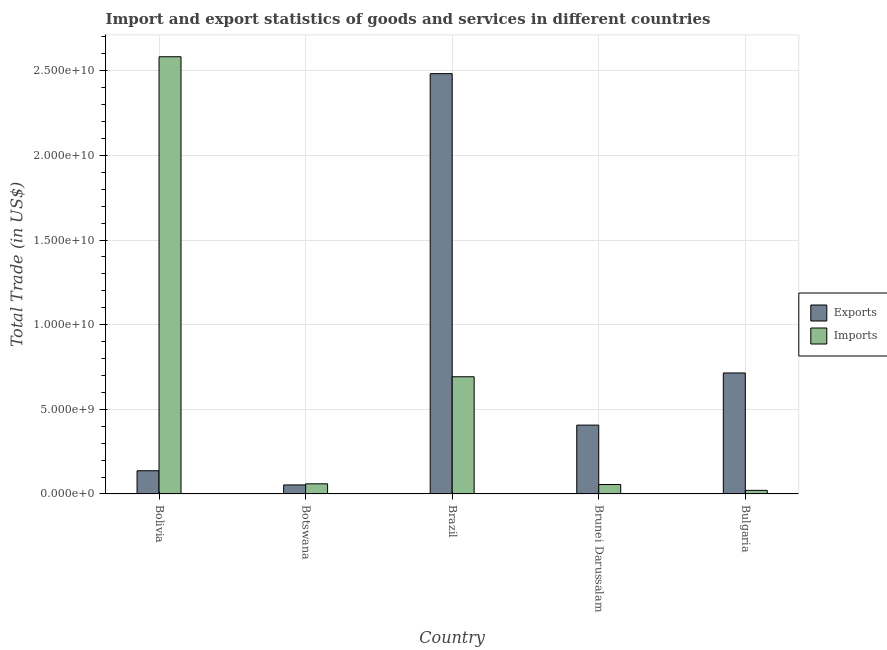Are the number of bars per tick equal to the number of legend labels?
Keep it short and to the point. Yes. Are the number of bars on each tick of the X-axis equal?
Offer a terse response. Yes. How many bars are there on the 2nd tick from the right?
Offer a terse response. 2. In how many cases, is the number of bars for a given country not equal to the number of legend labels?
Provide a short and direct response. 0. What is the export of goods and services in Bolivia?
Give a very brief answer. 1.37e+09. Across all countries, what is the maximum export of goods and services?
Your response must be concise. 2.48e+1. Across all countries, what is the minimum export of goods and services?
Give a very brief answer. 5.34e+08. In which country was the export of goods and services minimum?
Your answer should be very brief. Botswana. What is the total export of goods and services in the graph?
Your answer should be compact. 3.79e+1. What is the difference between the imports of goods and services in Bolivia and that in Brunei Darussalam?
Give a very brief answer. 2.53e+1. What is the difference between the imports of goods and services in Bolivia and the export of goods and services in Brazil?
Your answer should be very brief. 9.99e+08. What is the average imports of goods and services per country?
Provide a succinct answer. 6.82e+09. What is the difference between the imports of goods and services and export of goods and services in Bulgaria?
Your answer should be very brief. -6.93e+09. What is the ratio of the imports of goods and services in Botswana to that in Brunei Darussalam?
Keep it short and to the point. 1.07. Is the imports of goods and services in Bolivia less than that in Brunei Darussalam?
Keep it short and to the point. No. Is the difference between the imports of goods and services in Bolivia and Bulgaria greater than the difference between the export of goods and services in Bolivia and Bulgaria?
Your answer should be compact. Yes. What is the difference between the highest and the second highest imports of goods and services?
Your response must be concise. 1.89e+1. What is the difference between the highest and the lowest export of goods and services?
Ensure brevity in your answer.  2.43e+1. Is the sum of the export of goods and services in Bolivia and Brazil greater than the maximum imports of goods and services across all countries?
Make the answer very short. Yes. What does the 2nd bar from the left in Bolivia represents?
Offer a terse response. Imports. What does the 2nd bar from the right in Botswana represents?
Offer a very short reply. Exports. How many bars are there?
Ensure brevity in your answer.  10. What is the difference between two consecutive major ticks on the Y-axis?
Offer a very short reply. 5.00e+09. Does the graph contain any zero values?
Ensure brevity in your answer.  No. What is the title of the graph?
Ensure brevity in your answer.  Import and export statistics of goods and services in different countries. What is the label or title of the Y-axis?
Ensure brevity in your answer.  Total Trade (in US$). What is the Total Trade (in US$) of Exports in Bolivia?
Your response must be concise. 1.37e+09. What is the Total Trade (in US$) in Imports in Bolivia?
Keep it short and to the point. 2.58e+1. What is the Total Trade (in US$) in Exports in Botswana?
Offer a very short reply. 5.34e+08. What is the Total Trade (in US$) of Imports in Botswana?
Give a very brief answer. 5.99e+08. What is the Total Trade (in US$) in Exports in Brazil?
Your answer should be compact. 2.48e+1. What is the Total Trade (in US$) in Imports in Brazil?
Give a very brief answer. 6.92e+09. What is the Total Trade (in US$) in Exports in Brunei Darussalam?
Your answer should be very brief. 4.07e+09. What is the Total Trade (in US$) of Imports in Brunei Darussalam?
Ensure brevity in your answer.  5.58e+08. What is the Total Trade (in US$) in Exports in Bulgaria?
Ensure brevity in your answer.  7.15e+09. What is the Total Trade (in US$) of Imports in Bulgaria?
Ensure brevity in your answer.  2.14e+08. Across all countries, what is the maximum Total Trade (in US$) of Exports?
Ensure brevity in your answer.  2.48e+1. Across all countries, what is the maximum Total Trade (in US$) of Imports?
Offer a very short reply. 2.58e+1. Across all countries, what is the minimum Total Trade (in US$) of Exports?
Provide a short and direct response. 5.34e+08. Across all countries, what is the minimum Total Trade (in US$) in Imports?
Give a very brief answer. 2.14e+08. What is the total Total Trade (in US$) in Exports in the graph?
Offer a terse response. 3.79e+1. What is the total Total Trade (in US$) in Imports in the graph?
Your response must be concise. 3.41e+1. What is the difference between the Total Trade (in US$) in Exports in Bolivia and that in Botswana?
Provide a short and direct response. 8.37e+08. What is the difference between the Total Trade (in US$) of Imports in Bolivia and that in Botswana?
Keep it short and to the point. 2.52e+1. What is the difference between the Total Trade (in US$) in Exports in Bolivia and that in Brazil?
Give a very brief answer. -2.35e+1. What is the difference between the Total Trade (in US$) in Imports in Bolivia and that in Brazil?
Your answer should be very brief. 1.89e+1. What is the difference between the Total Trade (in US$) of Exports in Bolivia and that in Brunei Darussalam?
Give a very brief answer. -2.70e+09. What is the difference between the Total Trade (in US$) of Imports in Bolivia and that in Brunei Darussalam?
Give a very brief answer. 2.53e+1. What is the difference between the Total Trade (in US$) of Exports in Bolivia and that in Bulgaria?
Your answer should be compact. -5.78e+09. What is the difference between the Total Trade (in US$) in Imports in Bolivia and that in Bulgaria?
Give a very brief answer. 2.56e+1. What is the difference between the Total Trade (in US$) in Exports in Botswana and that in Brazil?
Your response must be concise. -2.43e+1. What is the difference between the Total Trade (in US$) of Imports in Botswana and that in Brazil?
Keep it short and to the point. -6.33e+09. What is the difference between the Total Trade (in US$) in Exports in Botswana and that in Brunei Darussalam?
Provide a short and direct response. -3.53e+09. What is the difference between the Total Trade (in US$) in Imports in Botswana and that in Brunei Darussalam?
Offer a very short reply. 4.05e+07. What is the difference between the Total Trade (in US$) of Exports in Botswana and that in Bulgaria?
Your answer should be very brief. -6.61e+09. What is the difference between the Total Trade (in US$) of Imports in Botswana and that in Bulgaria?
Your answer should be compact. 3.85e+08. What is the difference between the Total Trade (in US$) in Exports in Brazil and that in Brunei Darussalam?
Your answer should be compact. 2.08e+1. What is the difference between the Total Trade (in US$) in Imports in Brazil and that in Brunei Darussalam?
Your answer should be compact. 6.37e+09. What is the difference between the Total Trade (in US$) of Exports in Brazil and that in Bulgaria?
Give a very brief answer. 1.77e+1. What is the difference between the Total Trade (in US$) in Imports in Brazil and that in Bulgaria?
Your answer should be compact. 6.71e+09. What is the difference between the Total Trade (in US$) in Exports in Brunei Darussalam and that in Bulgaria?
Ensure brevity in your answer.  -3.08e+09. What is the difference between the Total Trade (in US$) in Imports in Brunei Darussalam and that in Bulgaria?
Give a very brief answer. 3.45e+08. What is the difference between the Total Trade (in US$) in Exports in Bolivia and the Total Trade (in US$) in Imports in Botswana?
Ensure brevity in your answer.  7.72e+08. What is the difference between the Total Trade (in US$) in Exports in Bolivia and the Total Trade (in US$) in Imports in Brazil?
Offer a terse response. -5.55e+09. What is the difference between the Total Trade (in US$) in Exports in Bolivia and the Total Trade (in US$) in Imports in Brunei Darussalam?
Keep it short and to the point. 8.13e+08. What is the difference between the Total Trade (in US$) of Exports in Bolivia and the Total Trade (in US$) of Imports in Bulgaria?
Offer a terse response. 1.16e+09. What is the difference between the Total Trade (in US$) in Exports in Botswana and the Total Trade (in US$) in Imports in Brazil?
Your answer should be compact. -6.39e+09. What is the difference between the Total Trade (in US$) of Exports in Botswana and the Total Trade (in US$) of Imports in Brunei Darussalam?
Offer a terse response. -2.45e+07. What is the difference between the Total Trade (in US$) in Exports in Botswana and the Total Trade (in US$) in Imports in Bulgaria?
Ensure brevity in your answer.  3.20e+08. What is the difference between the Total Trade (in US$) in Exports in Brazil and the Total Trade (in US$) in Imports in Brunei Darussalam?
Your answer should be very brief. 2.43e+1. What is the difference between the Total Trade (in US$) in Exports in Brazil and the Total Trade (in US$) in Imports in Bulgaria?
Give a very brief answer. 2.46e+1. What is the difference between the Total Trade (in US$) of Exports in Brunei Darussalam and the Total Trade (in US$) of Imports in Bulgaria?
Offer a terse response. 3.85e+09. What is the average Total Trade (in US$) in Exports per country?
Your response must be concise. 7.59e+09. What is the average Total Trade (in US$) of Imports per country?
Provide a succinct answer. 6.82e+09. What is the difference between the Total Trade (in US$) in Exports and Total Trade (in US$) in Imports in Bolivia?
Offer a very short reply. -2.45e+1. What is the difference between the Total Trade (in US$) of Exports and Total Trade (in US$) of Imports in Botswana?
Your response must be concise. -6.50e+07. What is the difference between the Total Trade (in US$) in Exports and Total Trade (in US$) in Imports in Brazil?
Your answer should be compact. 1.79e+1. What is the difference between the Total Trade (in US$) in Exports and Total Trade (in US$) in Imports in Brunei Darussalam?
Provide a short and direct response. 3.51e+09. What is the difference between the Total Trade (in US$) of Exports and Total Trade (in US$) of Imports in Bulgaria?
Offer a very short reply. 6.93e+09. What is the ratio of the Total Trade (in US$) in Exports in Bolivia to that in Botswana?
Provide a short and direct response. 2.57. What is the ratio of the Total Trade (in US$) in Imports in Bolivia to that in Botswana?
Offer a terse response. 43.13. What is the ratio of the Total Trade (in US$) of Exports in Bolivia to that in Brazil?
Offer a terse response. 0.06. What is the ratio of the Total Trade (in US$) in Imports in Bolivia to that in Brazil?
Offer a very short reply. 3.73. What is the ratio of the Total Trade (in US$) of Exports in Bolivia to that in Brunei Darussalam?
Your answer should be very brief. 0.34. What is the ratio of the Total Trade (in US$) in Imports in Bolivia to that in Brunei Darussalam?
Keep it short and to the point. 46.27. What is the ratio of the Total Trade (in US$) in Exports in Bolivia to that in Bulgaria?
Provide a succinct answer. 0.19. What is the ratio of the Total Trade (in US$) of Imports in Bolivia to that in Bulgaria?
Offer a very short reply. 120.94. What is the ratio of the Total Trade (in US$) in Exports in Botswana to that in Brazil?
Your answer should be very brief. 0.02. What is the ratio of the Total Trade (in US$) in Imports in Botswana to that in Brazil?
Give a very brief answer. 0.09. What is the ratio of the Total Trade (in US$) of Exports in Botswana to that in Brunei Darussalam?
Make the answer very short. 0.13. What is the ratio of the Total Trade (in US$) of Imports in Botswana to that in Brunei Darussalam?
Your answer should be compact. 1.07. What is the ratio of the Total Trade (in US$) of Exports in Botswana to that in Bulgaria?
Offer a terse response. 0.07. What is the ratio of the Total Trade (in US$) of Imports in Botswana to that in Bulgaria?
Your answer should be very brief. 2.8. What is the ratio of the Total Trade (in US$) in Exports in Brazil to that in Brunei Darussalam?
Keep it short and to the point. 6.11. What is the ratio of the Total Trade (in US$) in Imports in Brazil to that in Brunei Darussalam?
Your response must be concise. 12.4. What is the ratio of the Total Trade (in US$) of Exports in Brazil to that in Bulgaria?
Ensure brevity in your answer.  3.47. What is the ratio of the Total Trade (in US$) in Imports in Brazil to that in Bulgaria?
Give a very brief answer. 32.42. What is the ratio of the Total Trade (in US$) in Exports in Brunei Darussalam to that in Bulgaria?
Give a very brief answer. 0.57. What is the ratio of the Total Trade (in US$) in Imports in Brunei Darussalam to that in Bulgaria?
Keep it short and to the point. 2.61. What is the difference between the highest and the second highest Total Trade (in US$) in Exports?
Your answer should be very brief. 1.77e+1. What is the difference between the highest and the second highest Total Trade (in US$) in Imports?
Your answer should be very brief. 1.89e+1. What is the difference between the highest and the lowest Total Trade (in US$) in Exports?
Offer a terse response. 2.43e+1. What is the difference between the highest and the lowest Total Trade (in US$) of Imports?
Provide a succinct answer. 2.56e+1. 